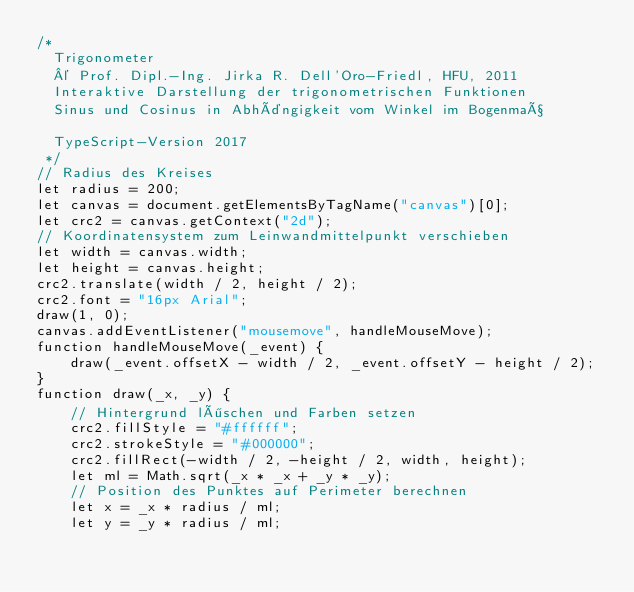<code> <loc_0><loc_0><loc_500><loc_500><_JavaScript_>/*
  Trigonometer
  © Prof. Dipl.-Ing. Jirka R. Dell'Oro-Friedl, HFU, 2011
  Interaktive Darstellung der trigonometrischen Funktionen
  Sinus und Cosinus in Abhängigkeit vom Winkel im Bogenmaß

  TypeScript-Version 2017
 */
// Radius des Kreises
let radius = 200;
let canvas = document.getElementsByTagName("canvas")[0];
let crc2 = canvas.getContext("2d");
// Koordinatensystem zum Leinwandmittelpunkt verschieben
let width = canvas.width;
let height = canvas.height;
crc2.translate(width / 2, height / 2);
crc2.font = "16px Arial";
draw(1, 0);
canvas.addEventListener("mousemove", handleMouseMove);
function handleMouseMove(_event) {
    draw(_event.offsetX - width / 2, _event.offsetY - height / 2);
}
function draw(_x, _y) {
    // Hintergrund löschen und Farben setzen
    crc2.fillStyle = "#ffffff";
    crc2.strokeStyle = "#000000";
    crc2.fillRect(-width / 2, -height / 2, width, height);
    let ml = Math.sqrt(_x * _x + _y * _y);
    // Position des Punktes auf Perimeter berechnen
    let x = _x * radius / ml;
    let y = _y * radius / ml;</code> 